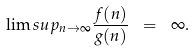<formula> <loc_0><loc_0><loc_500><loc_500>\lim s u p _ { n \rightarrow \infty } \frac { f ( n ) } { g ( n ) } \ = \ \infty .</formula> 